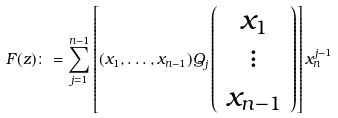<formula> <loc_0><loc_0><loc_500><loc_500>F ( z ) \colon = \sum _ { j = 1 } ^ { n - 1 } \left [ ( x _ { 1 } , \dots , x _ { n - 1 } ) Q _ { j } \left ( \begin{array} { c } x _ { 1 } \\ \vdots \\ x _ { n - 1 } \end{array} \right ) \right ] x _ { n } ^ { j - 1 }</formula> 